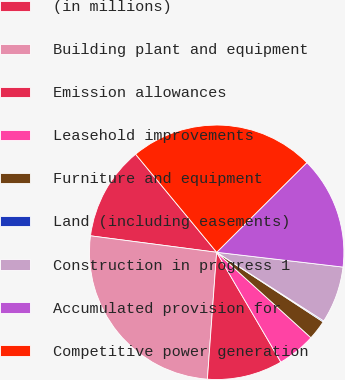Convert chart to OTSL. <chart><loc_0><loc_0><loc_500><loc_500><pie_chart><fcel>(in millions)<fcel>Building plant and equipment<fcel>Emission allowances<fcel>Leasehold improvements<fcel>Furniture and equipment<fcel>Land (including easements)<fcel>Construction in progress 1<fcel>Accumulated provision for<fcel>Competitive power generation<nl><fcel>11.94%<fcel>25.9%<fcel>9.58%<fcel>4.86%<fcel>2.5%<fcel>0.14%<fcel>7.22%<fcel>14.3%<fcel>23.54%<nl></chart> 